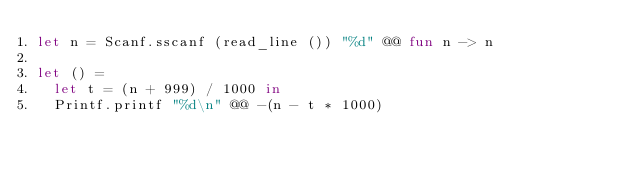Convert code to text. <code><loc_0><loc_0><loc_500><loc_500><_OCaml_>let n = Scanf.sscanf (read_line ()) "%d" @@ fun n -> n

let () = 
  let t = (n + 999) / 1000 in
  Printf.printf "%d\n" @@ -(n - t * 1000)</code> 